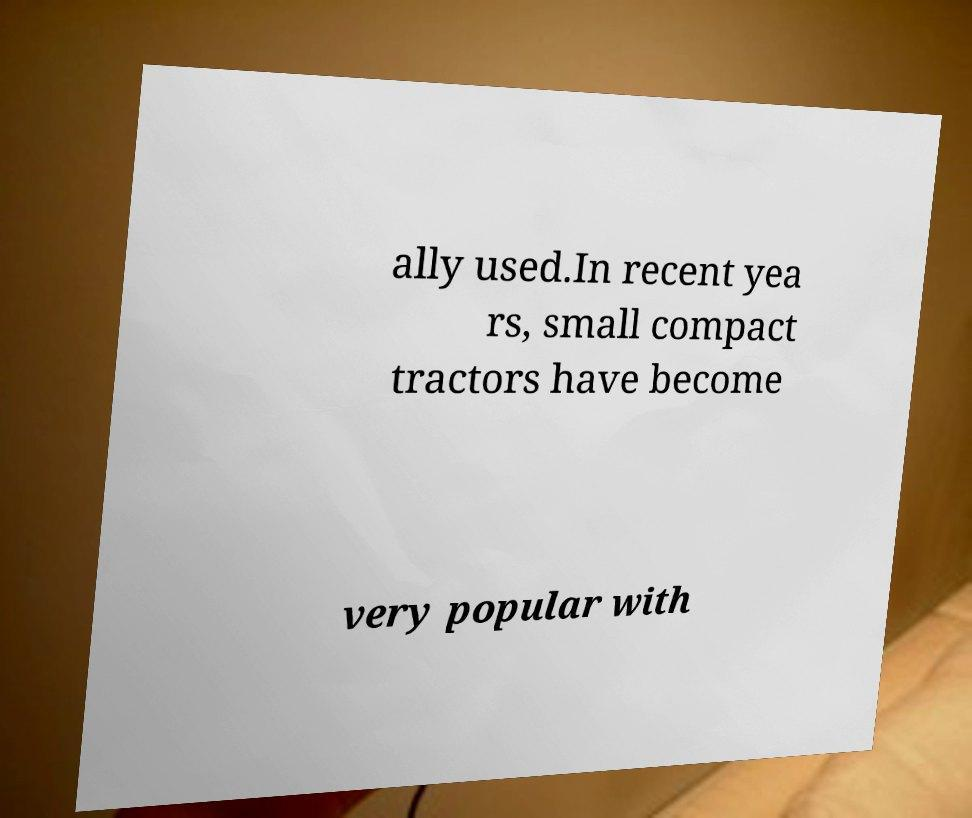There's text embedded in this image that I need extracted. Can you transcribe it verbatim? ally used.In recent yea rs, small compact tractors have become very popular with 